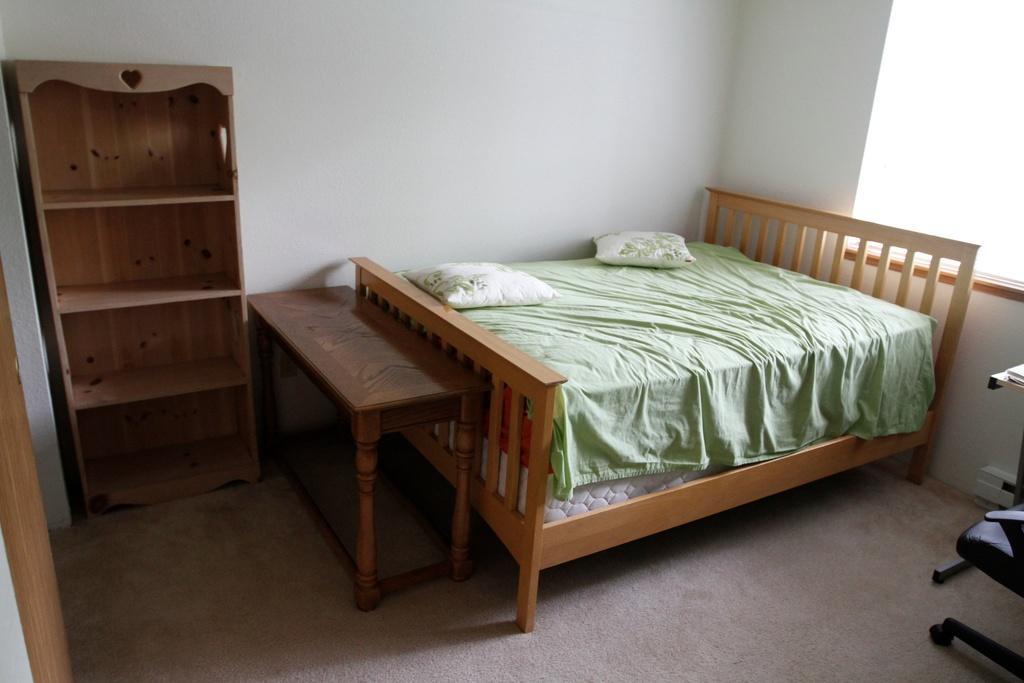In one or two sentences, can you explain what this image depicts? This is inside view of a room. We can see rack stand, bed, pillows on the bed, chair are there on the floor and we can see window, wall and objects. 